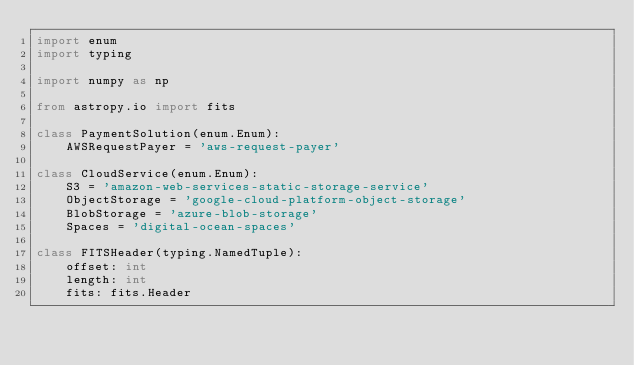<code> <loc_0><loc_0><loc_500><loc_500><_Python_>import enum
import typing

import numpy as np

from astropy.io import fits

class PaymentSolution(enum.Enum):
    AWSRequestPayer = 'aws-request-payer'

class CloudService(enum.Enum):
    S3 = 'amazon-web-services-static-storage-service'
    ObjectStorage = 'google-cloud-platform-object-storage'
    BlobStorage = 'azure-blob-storage'
    Spaces = 'digital-ocean-spaces'

class FITSHeader(typing.NamedTuple):
    offset: int
    length: int
    fits: fits.Header
</code> 